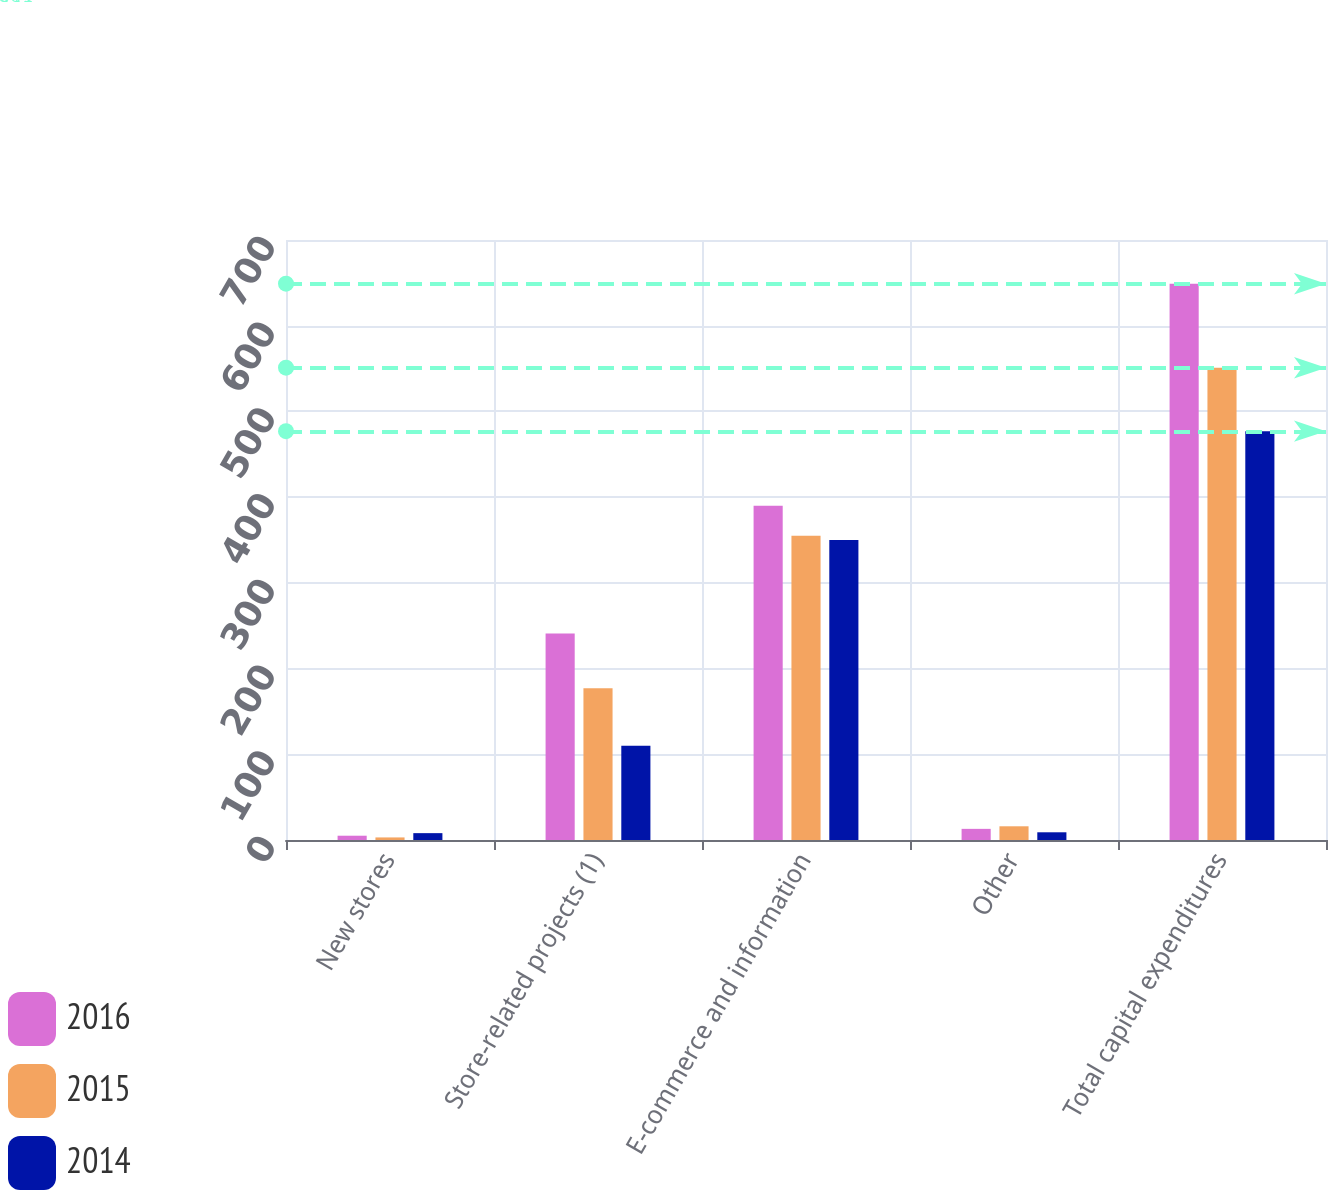Convert chart. <chart><loc_0><loc_0><loc_500><loc_500><stacked_bar_chart><ecel><fcel>New stores<fcel>Store-related projects (1)<fcel>E-commerce and information<fcel>Other<fcel>Total capital expenditures<nl><fcel>2016<fcel>5<fcel>241<fcel>390<fcel>13<fcel>649<nl><fcel>2015<fcel>3<fcel>177<fcel>355<fcel>16<fcel>551<nl><fcel>2014<fcel>8<fcel>110<fcel>350<fcel>9<fcel>477<nl></chart> 